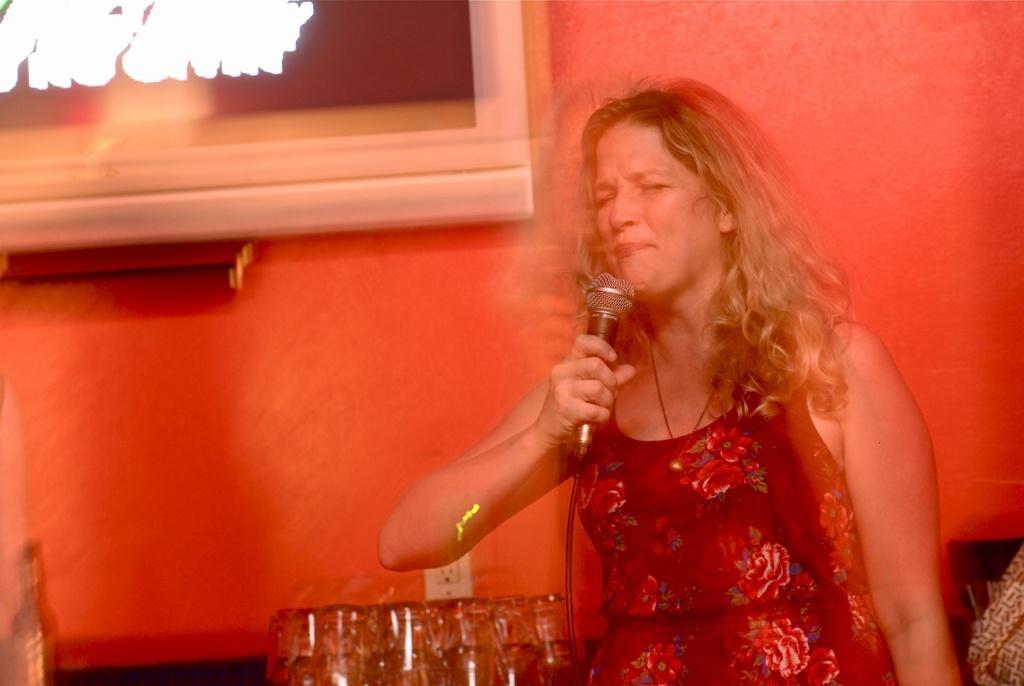In one or two sentences, can you explain what this image depicts? On the right of this picture we can see a woman wearing dress, holding a microphone and standing. In the background we can see an object attached to the wall and we can see the glasses, wall socket and some other objects. 